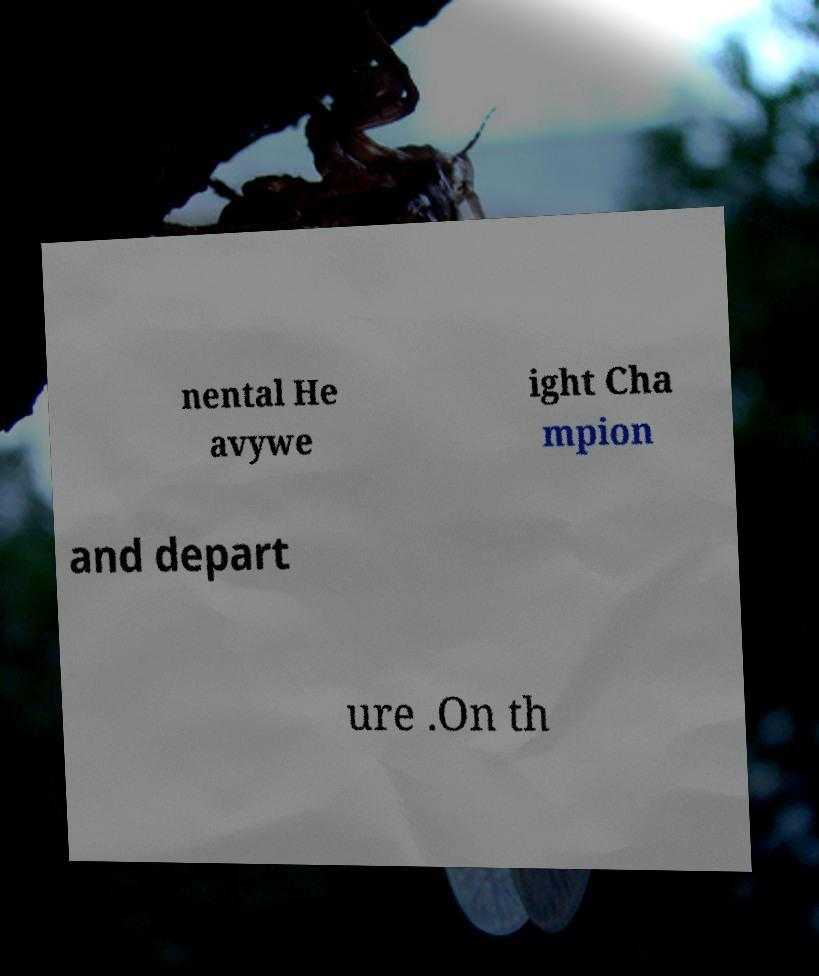For documentation purposes, I need the text within this image transcribed. Could you provide that? nental He avywe ight Cha mpion and depart ure .On th 